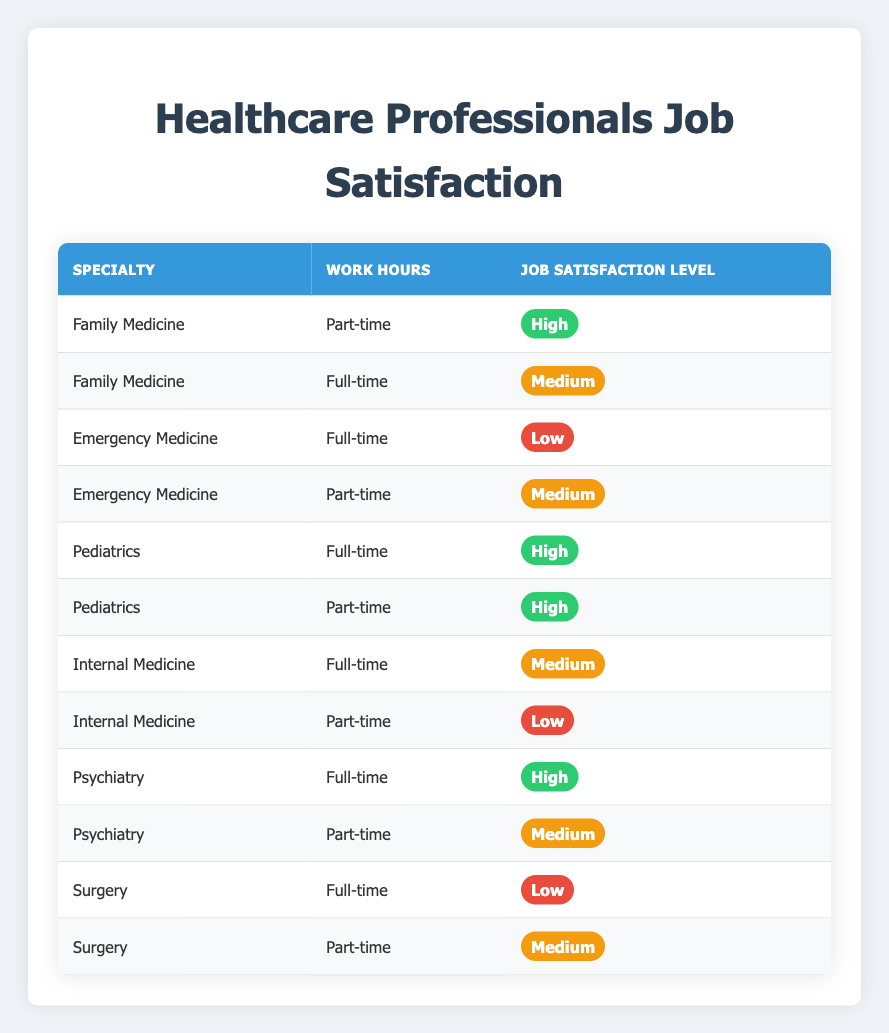What is the job satisfaction level for "Family Medicine" with "Part-time" work hours? In the table, the row for "Family Medicine" with "Part-time" work hours shows the job satisfaction level as "High."
Answer: High How many specialties have a "Low" job satisfaction level in "Full-time" work hours? There are two entries for "Full-time" work hours with a "Low" job satisfaction level: one for "Emergency Medicine" and one for "Surgery." Thus, the count is 2.
Answer: 2 Is "Pediatrics" associated only with "High" job satisfaction levels? There are two entries for "Pediatrics," one for "Full-time" and one for "Part-time," both of which have a "High" job satisfaction level. Hence, the answer is yes.
Answer: Yes What is the average job satisfaction level among the specialties for "Part-time" work hours? The "Part-time" entries show "High" for Family Medicine, Pediatrics, and Psychiatry, "Medium" for Psychiatry, and "Low" for Internal Medicine. To average it: High (2) + Medium (1) + Low (1) = 2 + 1 + 0 = 3 (on a scale of 0-2), so average = 3 / 5 = 0.6, approximating High.
Answer: High Which specialty has the highest number of "High" job satisfaction levels across all work hours? From the table, "Pediatrics" has two entries, both showing "High" (for both Full-time and Part-time). No other specialty has more than one "High." Thus, Pediatrics has the highest number.
Answer: Pediatrics How many specialties show a "Medium" job satisfaction level? Upon reviewing the table, "Family Medicine," "Emergency Medicine," "Internal Medicine," and "Psychiatry" all list "Medium" job satisfaction levels at least once. Therefore, the count of unique specialties is 4.
Answer: 4 Is the "Psychiatry" specialty associated with only "High" job satisfaction for Full-time employees? The entry for "Psychiatry" with "Full-time" work hours shows "High," but the "Part-time" entry shows "Medium." Thus, Psychiatry is not associated only with "High."
Answer: No Among the specialties listed, which work hours have the highest job satisfaction level? After examining the table, both "Family Medicine," "Pediatrics," and "Psychiatry" for "Part-time" show "High," indicating Part-time works have the highest satisfaction.
Answer: Part-time 